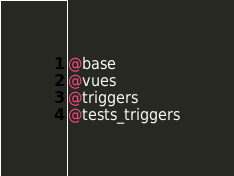<code> <loc_0><loc_0><loc_500><loc_500><_SQL_>
@base
@vues
@triggers
@tests_triggers
</code> 